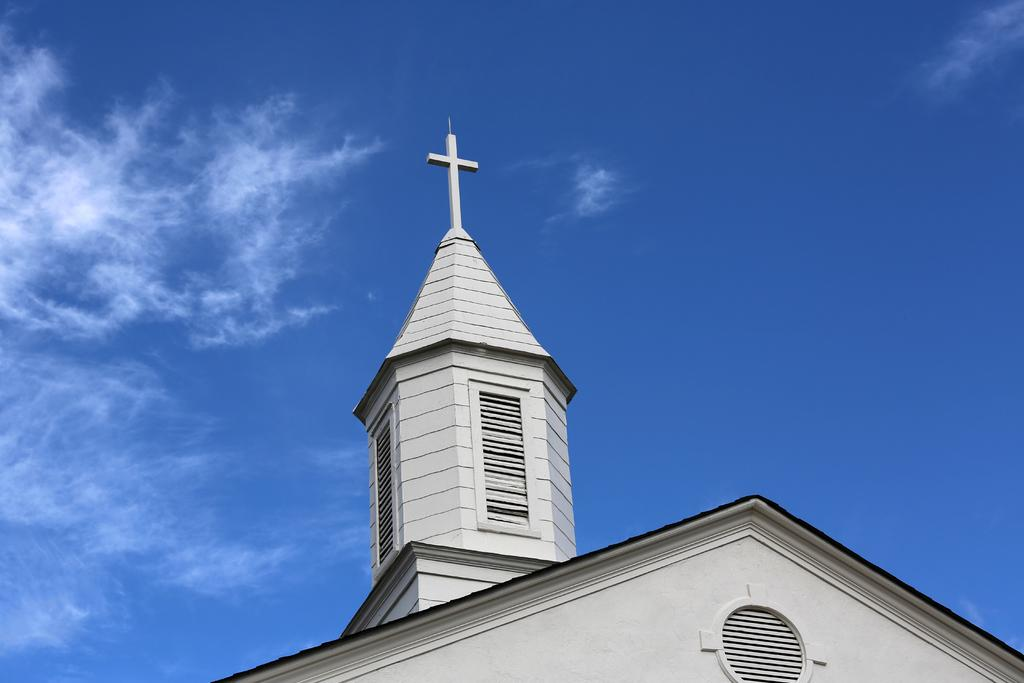What is the main structure in the front of the image? There is a building in the front of the image. What religious symbol can be seen in the image? There is a Christianity symbol in the middle of the image. What can be seen in the background of the image? The sky is visible in the background of the image. Where is the bottle located in the image? There is no bottle present in the image. What type of advertisement can be seen in the image? There is no advertisement present in the image. 